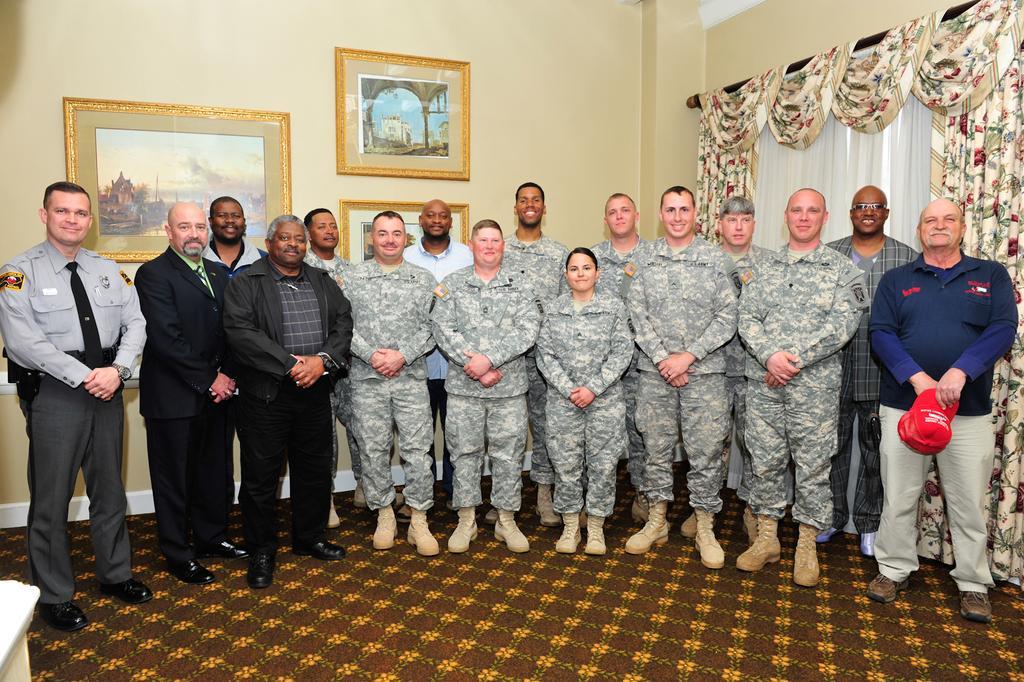Please provide a concise description of this image. This image is clicked inside a room. There is curtain on the right side. There are photo frames in the middle. There are some persons standing in the middle. Some are in military dress. All are wearing shoes. 